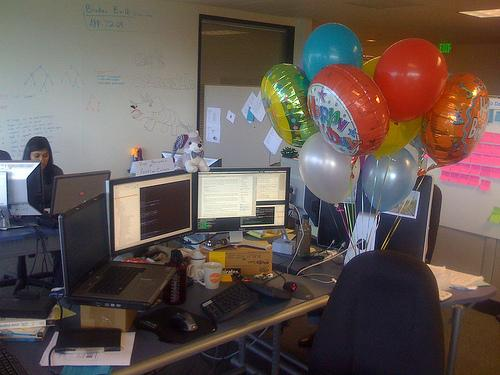Describe the appearance of a laptop in the image. A black laptop computer is in an open position but not turned on. Identify the type of animal depicted as a stuffed toy in the image. There is a small stuffed dog with a winter hat. Please count the total number of balloons in the image. There are a lot of balloons, including a red mylar balloon, an inflated white rubber balloon, and a bunch of helium balloons. What kind of messages are on the balloons in the image? There is a red mylar balloon with a message, but the specific message is not noted in the description. Is there any person in the image? If yes, describe the person. Yes, there is a young woman working in her office, and a girl with brown hair looking down. What type of chair is present in the image? Provide a description. A black office desk chair and the rear of a black office chair are present in the image. What type of notes can be found in the image, and where are they? There are multiple pink sticky notes on the whiteboard, and a used post-it note is stuck to the wall. What objects are situated on the computer desk? There are two computer monitors, a black keyboard attached to the monitors, a laptop, a black mousepad, a silver cordless computer mouse, a beige and orange mug, a white coffee cup with an orange logo, and a water bottle on the desk. What item has a drawing on it? There is a drawing of a triceratops on a whiteboard in the office. How many computer monitors can be seen? Are they of the same type? There are two computer monitors - two flatscreen black framed monitors, and two wide screen monitors side by side. Describe the color and design of the coffee mug on the desk. Orange and white, with an orange logo on the white part Where is the blue stapler on top of the small closed cardboard box? No, it's not mentioned in the image. What is the color and state of the dry erase board from the image? White with writing on it Which item is positioned behind the people in the image? Large white board What type of computer mouse is presented in the image? Silver cordless computer mouse Please describe the state and color of the laptop computer in the image. Black laptop, not turned on There's an animal figure with a particular accessory on it. Identify the accessory. Winter hat What activity is the girl with brown hair doing in the image? Looking down What is the main color of the computer desk in the image? Grey What is the color of the balloons in the image? Multiple and colorful Select the correct description of the office chair in the image.  b) Black office desk chair There are two computer monitors. How are they positioned in relation to each other? Side by side What type of monitor does the computer have in the image? Widescreen computer monitor What is the condition of the laptop in the image? It has no power and is in open position The image features a bunch of balloons filled with a particular type of gas. What is the gas they are filled with? Helium In the image, what type of writing is found on the post-it notes? Used Identify the two items that are next to each other on the desk. Two computer tv monitors and a black keyboard attached to the monitors Describe the stuffed animal that is in the image. Small stuffed dog with a winter hat Describe the position and expression of the woman working in the office. Sitting at her desk, looking down What device is next to the laptop? Black keyboard What type of animal is depicted in a drawing in the image? Triceratops 